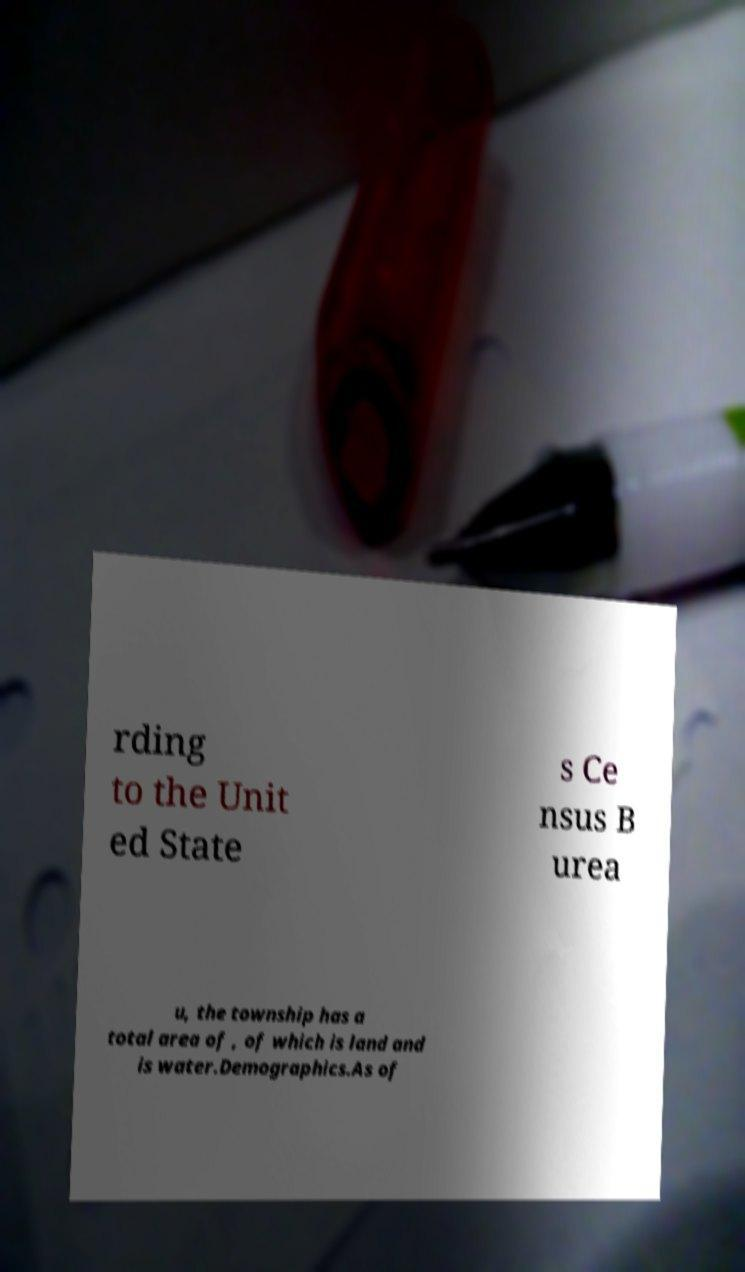I need the written content from this picture converted into text. Can you do that? rding to the Unit ed State s Ce nsus B urea u, the township has a total area of , of which is land and is water.Demographics.As of 